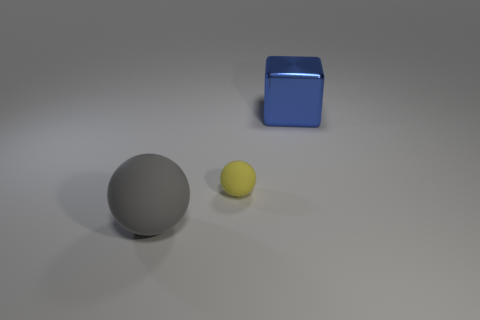There is a ball behind the big object in front of the big metal object right of the yellow object; what color is it?
Your response must be concise. Yellow. There is a shiny thing that is the same size as the gray ball; what color is it?
Make the answer very short. Blue. How many rubber things are balls or big blue things?
Make the answer very short. 2. There is a large object that is made of the same material as the small yellow object; what is its color?
Provide a short and direct response. Gray. What material is the sphere that is on the right side of the large thing in front of the large metallic block?
Provide a short and direct response. Rubber. How many objects are either objects right of the gray rubber ball or objects left of the small thing?
Ensure brevity in your answer.  3. There is a matte thing that is left of the ball on the right side of the large object to the left of the metallic object; how big is it?
Offer a terse response. Large. Are there an equal number of large metallic blocks that are on the left side of the blue cube and small cyan cylinders?
Keep it short and to the point. Yes. Are there any other things that are the same shape as the big blue thing?
Offer a very short reply. No. Does the big gray thing have the same shape as the big blue object to the right of the yellow rubber sphere?
Keep it short and to the point. No. 